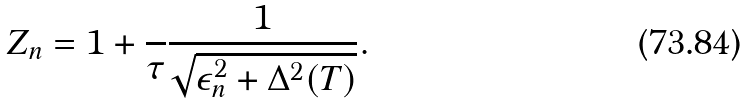<formula> <loc_0><loc_0><loc_500><loc_500>Z _ { n } = 1 + \frac { } { \tau } \frac { 1 } { \sqrt { \epsilon _ { n } ^ { 2 } + \Delta ^ { 2 } ( T ) } } .</formula> 